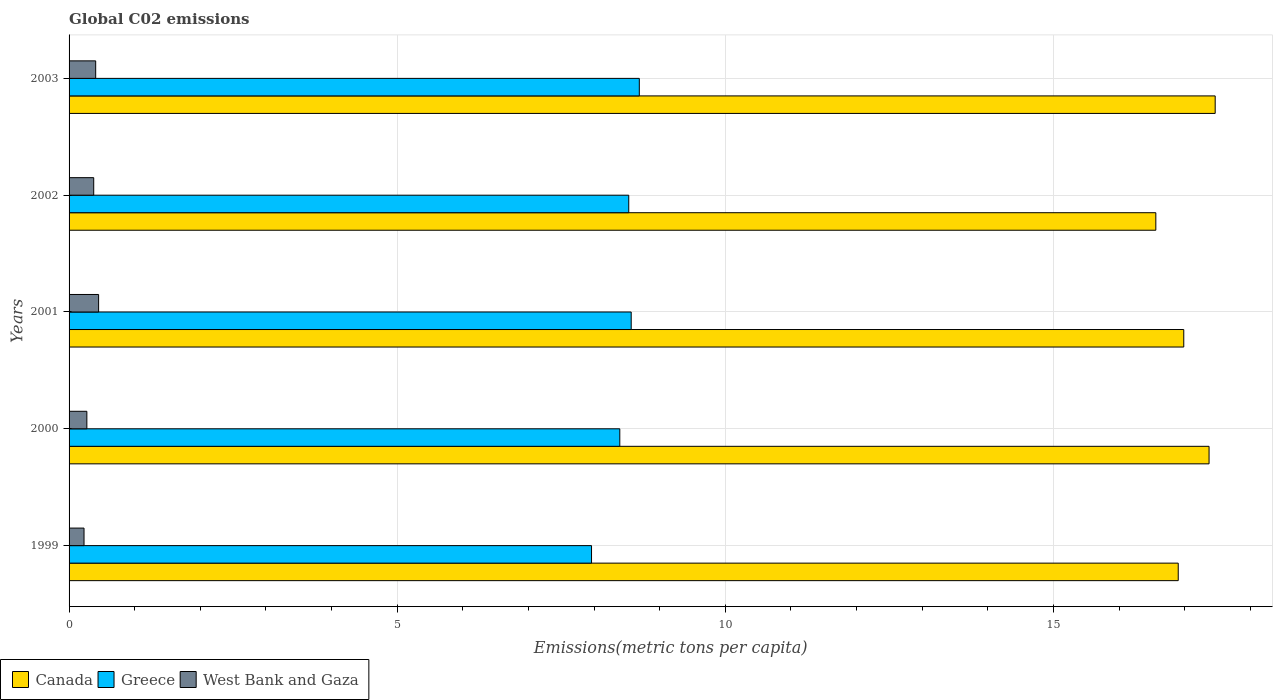How many different coloured bars are there?
Your answer should be compact. 3. How many groups of bars are there?
Provide a succinct answer. 5. Are the number of bars on each tick of the Y-axis equal?
Make the answer very short. Yes. How many bars are there on the 4th tick from the top?
Your answer should be compact. 3. What is the label of the 1st group of bars from the top?
Keep it short and to the point. 2003. In how many cases, is the number of bars for a given year not equal to the number of legend labels?
Your answer should be very brief. 0. What is the amount of CO2 emitted in in Canada in 2000?
Your response must be concise. 17.37. Across all years, what is the maximum amount of CO2 emitted in in West Bank and Gaza?
Keep it short and to the point. 0.45. Across all years, what is the minimum amount of CO2 emitted in in Greece?
Offer a very short reply. 7.96. In which year was the amount of CO2 emitted in in West Bank and Gaza maximum?
Keep it short and to the point. 2001. What is the total amount of CO2 emitted in in Greece in the graph?
Your response must be concise. 42.14. What is the difference between the amount of CO2 emitted in in Canada in 2002 and that in 2003?
Provide a short and direct response. -0.9. What is the difference between the amount of CO2 emitted in in West Bank and Gaza in 2000 and the amount of CO2 emitted in in Canada in 2002?
Offer a terse response. -16.29. What is the average amount of CO2 emitted in in Canada per year?
Your answer should be compact. 17.06. In the year 2002, what is the difference between the amount of CO2 emitted in in West Bank and Gaza and amount of CO2 emitted in in Greece?
Make the answer very short. -8.15. In how many years, is the amount of CO2 emitted in in West Bank and Gaza greater than 8 metric tons per capita?
Offer a very short reply. 0. What is the ratio of the amount of CO2 emitted in in Greece in 1999 to that in 2000?
Give a very brief answer. 0.95. Is the amount of CO2 emitted in in Greece in 1999 less than that in 2000?
Your answer should be compact. Yes. What is the difference between the highest and the second highest amount of CO2 emitted in in Canada?
Your answer should be very brief. 0.09. What is the difference between the highest and the lowest amount of CO2 emitted in in Canada?
Provide a succinct answer. 0.9. Is the sum of the amount of CO2 emitted in in Canada in 2001 and 2002 greater than the maximum amount of CO2 emitted in in West Bank and Gaza across all years?
Keep it short and to the point. Yes. What does the 3rd bar from the bottom in 2002 represents?
Your answer should be very brief. West Bank and Gaza. Is it the case that in every year, the sum of the amount of CO2 emitted in in West Bank and Gaza and amount of CO2 emitted in in Greece is greater than the amount of CO2 emitted in in Canada?
Provide a succinct answer. No. How many bars are there?
Your answer should be compact. 15. Are all the bars in the graph horizontal?
Provide a succinct answer. Yes. What is the difference between two consecutive major ticks on the X-axis?
Your answer should be very brief. 5. How are the legend labels stacked?
Ensure brevity in your answer.  Horizontal. What is the title of the graph?
Provide a short and direct response. Global C02 emissions. Does "Syrian Arab Republic" appear as one of the legend labels in the graph?
Keep it short and to the point. No. What is the label or title of the X-axis?
Offer a very short reply. Emissions(metric tons per capita). What is the label or title of the Y-axis?
Keep it short and to the point. Years. What is the Emissions(metric tons per capita) of Canada in 1999?
Offer a terse response. 16.9. What is the Emissions(metric tons per capita) of Greece in 1999?
Make the answer very short. 7.96. What is the Emissions(metric tons per capita) of West Bank and Gaza in 1999?
Offer a very short reply. 0.23. What is the Emissions(metric tons per capita) of Canada in 2000?
Give a very brief answer. 17.37. What is the Emissions(metric tons per capita) of Greece in 2000?
Ensure brevity in your answer.  8.39. What is the Emissions(metric tons per capita) in West Bank and Gaza in 2000?
Offer a terse response. 0.27. What is the Emissions(metric tons per capita) in Canada in 2001?
Your answer should be very brief. 16.99. What is the Emissions(metric tons per capita) in Greece in 2001?
Offer a terse response. 8.57. What is the Emissions(metric tons per capita) in West Bank and Gaza in 2001?
Your answer should be compact. 0.45. What is the Emissions(metric tons per capita) in Canada in 2002?
Provide a succinct answer. 16.56. What is the Emissions(metric tons per capita) of Greece in 2002?
Keep it short and to the point. 8.53. What is the Emissions(metric tons per capita) in West Bank and Gaza in 2002?
Make the answer very short. 0.38. What is the Emissions(metric tons per capita) of Canada in 2003?
Provide a short and direct response. 17.46. What is the Emissions(metric tons per capita) of Greece in 2003?
Your answer should be compact. 8.69. What is the Emissions(metric tons per capita) of West Bank and Gaza in 2003?
Your answer should be very brief. 0.41. Across all years, what is the maximum Emissions(metric tons per capita) in Canada?
Your answer should be very brief. 17.46. Across all years, what is the maximum Emissions(metric tons per capita) in Greece?
Provide a succinct answer. 8.69. Across all years, what is the maximum Emissions(metric tons per capita) of West Bank and Gaza?
Give a very brief answer. 0.45. Across all years, what is the minimum Emissions(metric tons per capita) in Canada?
Your response must be concise. 16.56. Across all years, what is the minimum Emissions(metric tons per capita) in Greece?
Provide a short and direct response. 7.96. Across all years, what is the minimum Emissions(metric tons per capita) of West Bank and Gaza?
Give a very brief answer. 0.23. What is the total Emissions(metric tons per capita) in Canada in the graph?
Your response must be concise. 85.28. What is the total Emissions(metric tons per capita) of Greece in the graph?
Your answer should be very brief. 42.14. What is the total Emissions(metric tons per capita) in West Bank and Gaza in the graph?
Your answer should be compact. 1.73. What is the difference between the Emissions(metric tons per capita) of Canada in 1999 and that in 2000?
Provide a succinct answer. -0.47. What is the difference between the Emissions(metric tons per capita) of Greece in 1999 and that in 2000?
Give a very brief answer. -0.43. What is the difference between the Emissions(metric tons per capita) in West Bank and Gaza in 1999 and that in 2000?
Your answer should be compact. -0.04. What is the difference between the Emissions(metric tons per capita) in Canada in 1999 and that in 2001?
Provide a succinct answer. -0.08. What is the difference between the Emissions(metric tons per capita) of Greece in 1999 and that in 2001?
Offer a terse response. -0.6. What is the difference between the Emissions(metric tons per capita) of West Bank and Gaza in 1999 and that in 2001?
Provide a short and direct response. -0.22. What is the difference between the Emissions(metric tons per capita) of Canada in 1999 and that in 2002?
Your answer should be very brief. 0.34. What is the difference between the Emissions(metric tons per capita) of Greece in 1999 and that in 2002?
Make the answer very short. -0.57. What is the difference between the Emissions(metric tons per capita) of West Bank and Gaza in 1999 and that in 2002?
Provide a succinct answer. -0.15. What is the difference between the Emissions(metric tons per capita) of Canada in 1999 and that in 2003?
Your answer should be compact. -0.56. What is the difference between the Emissions(metric tons per capita) in Greece in 1999 and that in 2003?
Ensure brevity in your answer.  -0.73. What is the difference between the Emissions(metric tons per capita) in West Bank and Gaza in 1999 and that in 2003?
Your response must be concise. -0.18. What is the difference between the Emissions(metric tons per capita) in Canada in 2000 and that in 2001?
Your answer should be very brief. 0.39. What is the difference between the Emissions(metric tons per capita) of Greece in 2000 and that in 2001?
Make the answer very short. -0.17. What is the difference between the Emissions(metric tons per capita) in West Bank and Gaza in 2000 and that in 2001?
Offer a very short reply. -0.18. What is the difference between the Emissions(metric tons per capita) in Canada in 2000 and that in 2002?
Your answer should be compact. 0.81. What is the difference between the Emissions(metric tons per capita) of Greece in 2000 and that in 2002?
Your answer should be very brief. -0.14. What is the difference between the Emissions(metric tons per capita) of West Bank and Gaza in 2000 and that in 2002?
Give a very brief answer. -0.1. What is the difference between the Emissions(metric tons per capita) of Canada in 2000 and that in 2003?
Keep it short and to the point. -0.09. What is the difference between the Emissions(metric tons per capita) of Greece in 2000 and that in 2003?
Offer a terse response. -0.3. What is the difference between the Emissions(metric tons per capita) of West Bank and Gaza in 2000 and that in 2003?
Keep it short and to the point. -0.13. What is the difference between the Emissions(metric tons per capita) of Canada in 2001 and that in 2002?
Ensure brevity in your answer.  0.43. What is the difference between the Emissions(metric tons per capita) in Greece in 2001 and that in 2002?
Give a very brief answer. 0.04. What is the difference between the Emissions(metric tons per capita) of West Bank and Gaza in 2001 and that in 2002?
Your response must be concise. 0.07. What is the difference between the Emissions(metric tons per capita) in Canada in 2001 and that in 2003?
Offer a terse response. -0.48. What is the difference between the Emissions(metric tons per capita) of Greece in 2001 and that in 2003?
Give a very brief answer. -0.12. What is the difference between the Emissions(metric tons per capita) of West Bank and Gaza in 2001 and that in 2003?
Your response must be concise. 0.04. What is the difference between the Emissions(metric tons per capita) of Canada in 2002 and that in 2003?
Your answer should be compact. -0.9. What is the difference between the Emissions(metric tons per capita) in Greece in 2002 and that in 2003?
Offer a very short reply. -0.16. What is the difference between the Emissions(metric tons per capita) in West Bank and Gaza in 2002 and that in 2003?
Your answer should be very brief. -0.03. What is the difference between the Emissions(metric tons per capita) of Canada in 1999 and the Emissions(metric tons per capita) of Greece in 2000?
Offer a terse response. 8.51. What is the difference between the Emissions(metric tons per capita) in Canada in 1999 and the Emissions(metric tons per capita) in West Bank and Gaza in 2000?
Make the answer very short. 16.63. What is the difference between the Emissions(metric tons per capita) in Greece in 1999 and the Emissions(metric tons per capita) in West Bank and Gaza in 2000?
Provide a short and direct response. 7.69. What is the difference between the Emissions(metric tons per capita) in Canada in 1999 and the Emissions(metric tons per capita) in Greece in 2001?
Your answer should be compact. 8.34. What is the difference between the Emissions(metric tons per capita) of Canada in 1999 and the Emissions(metric tons per capita) of West Bank and Gaza in 2001?
Offer a terse response. 16.45. What is the difference between the Emissions(metric tons per capita) of Greece in 1999 and the Emissions(metric tons per capita) of West Bank and Gaza in 2001?
Provide a short and direct response. 7.51. What is the difference between the Emissions(metric tons per capita) of Canada in 1999 and the Emissions(metric tons per capita) of Greece in 2002?
Provide a succinct answer. 8.37. What is the difference between the Emissions(metric tons per capita) of Canada in 1999 and the Emissions(metric tons per capita) of West Bank and Gaza in 2002?
Ensure brevity in your answer.  16.53. What is the difference between the Emissions(metric tons per capita) in Greece in 1999 and the Emissions(metric tons per capita) in West Bank and Gaza in 2002?
Keep it short and to the point. 7.59. What is the difference between the Emissions(metric tons per capita) in Canada in 1999 and the Emissions(metric tons per capita) in Greece in 2003?
Offer a terse response. 8.21. What is the difference between the Emissions(metric tons per capita) of Canada in 1999 and the Emissions(metric tons per capita) of West Bank and Gaza in 2003?
Make the answer very short. 16.5. What is the difference between the Emissions(metric tons per capita) of Greece in 1999 and the Emissions(metric tons per capita) of West Bank and Gaza in 2003?
Give a very brief answer. 7.56. What is the difference between the Emissions(metric tons per capita) of Canada in 2000 and the Emissions(metric tons per capita) of Greece in 2001?
Your answer should be compact. 8.81. What is the difference between the Emissions(metric tons per capita) of Canada in 2000 and the Emissions(metric tons per capita) of West Bank and Gaza in 2001?
Your answer should be very brief. 16.92. What is the difference between the Emissions(metric tons per capita) of Greece in 2000 and the Emissions(metric tons per capita) of West Bank and Gaza in 2001?
Provide a short and direct response. 7.94. What is the difference between the Emissions(metric tons per capita) of Canada in 2000 and the Emissions(metric tons per capita) of Greece in 2002?
Provide a succinct answer. 8.84. What is the difference between the Emissions(metric tons per capita) of Canada in 2000 and the Emissions(metric tons per capita) of West Bank and Gaza in 2002?
Your answer should be compact. 16.99. What is the difference between the Emissions(metric tons per capita) of Greece in 2000 and the Emissions(metric tons per capita) of West Bank and Gaza in 2002?
Keep it short and to the point. 8.02. What is the difference between the Emissions(metric tons per capita) in Canada in 2000 and the Emissions(metric tons per capita) in Greece in 2003?
Your response must be concise. 8.68. What is the difference between the Emissions(metric tons per capita) in Canada in 2000 and the Emissions(metric tons per capita) in West Bank and Gaza in 2003?
Provide a succinct answer. 16.96. What is the difference between the Emissions(metric tons per capita) of Greece in 2000 and the Emissions(metric tons per capita) of West Bank and Gaza in 2003?
Keep it short and to the point. 7.99. What is the difference between the Emissions(metric tons per capita) in Canada in 2001 and the Emissions(metric tons per capita) in Greece in 2002?
Give a very brief answer. 8.46. What is the difference between the Emissions(metric tons per capita) of Canada in 2001 and the Emissions(metric tons per capita) of West Bank and Gaza in 2002?
Your answer should be very brief. 16.61. What is the difference between the Emissions(metric tons per capita) of Greece in 2001 and the Emissions(metric tons per capita) of West Bank and Gaza in 2002?
Offer a very short reply. 8.19. What is the difference between the Emissions(metric tons per capita) of Canada in 2001 and the Emissions(metric tons per capita) of Greece in 2003?
Keep it short and to the point. 8.3. What is the difference between the Emissions(metric tons per capita) of Canada in 2001 and the Emissions(metric tons per capita) of West Bank and Gaza in 2003?
Make the answer very short. 16.58. What is the difference between the Emissions(metric tons per capita) of Greece in 2001 and the Emissions(metric tons per capita) of West Bank and Gaza in 2003?
Make the answer very short. 8.16. What is the difference between the Emissions(metric tons per capita) in Canada in 2002 and the Emissions(metric tons per capita) in Greece in 2003?
Your answer should be very brief. 7.87. What is the difference between the Emissions(metric tons per capita) of Canada in 2002 and the Emissions(metric tons per capita) of West Bank and Gaza in 2003?
Make the answer very short. 16.15. What is the difference between the Emissions(metric tons per capita) of Greece in 2002 and the Emissions(metric tons per capita) of West Bank and Gaza in 2003?
Provide a succinct answer. 8.12. What is the average Emissions(metric tons per capita) of Canada per year?
Your answer should be very brief. 17.06. What is the average Emissions(metric tons per capita) of Greece per year?
Give a very brief answer. 8.43. What is the average Emissions(metric tons per capita) of West Bank and Gaza per year?
Offer a terse response. 0.35. In the year 1999, what is the difference between the Emissions(metric tons per capita) in Canada and Emissions(metric tons per capita) in Greece?
Make the answer very short. 8.94. In the year 1999, what is the difference between the Emissions(metric tons per capita) of Canada and Emissions(metric tons per capita) of West Bank and Gaza?
Your answer should be compact. 16.67. In the year 1999, what is the difference between the Emissions(metric tons per capita) of Greece and Emissions(metric tons per capita) of West Bank and Gaza?
Your answer should be compact. 7.73. In the year 2000, what is the difference between the Emissions(metric tons per capita) of Canada and Emissions(metric tons per capita) of Greece?
Provide a short and direct response. 8.98. In the year 2000, what is the difference between the Emissions(metric tons per capita) in Canada and Emissions(metric tons per capita) in West Bank and Gaza?
Keep it short and to the point. 17.1. In the year 2000, what is the difference between the Emissions(metric tons per capita) in Greece and Emissions(metric tons per capita) in West Bank and Gaza?
Keep it short and to the point. 8.12. In the year 2001, what is the difference between the Emissions(metric tons per capita) of Canada and Emissions(metric tons per capita) of Greece?
Your response must be concise. 8.42. In the year 2001, what is the difference between the Emissions(metric tons per capita) of Canada and Emissions(metric tons per capita) of West Bank and Gaza?
Make the answer very short. 16.53. In the year 2001, what is the difference between the Emissions(metric tons per capita) in Greece and Emissions(metric tons per capita) in West Bank and Gaza?
Ensure brevity in your answer.  8.12. In the year 2002, what is the difference between the Emissions(metric tons per capita) of Canada and Emissions(metric tons per capita) of Greece?
Offer a very short reply. 8.03. In the year 2002, what is the difference between the Emissions(metric tons per capita) of Canada and Emissions(metric tons per capita) of West Bank and Gaza?
Keep it short and to the point. 16.18. In the year 2002, what is the difference between the Emissions(metric tons per capita) of Greece and Emissions(metric tons per capita) of West Bank and Gaza?
Provide a succinct answer. 8.15. In the year 2003, what is the difference between the Emissions(metric tons per capita) in Canada and Emissions(metric tons per capita) in Greece?
Your answer should be very brief. 8.77. In the year 2003, what is the difference between the Emissions(metric tons per capita) in Canada and Emissions(metric tons per capita) in West Bank and Gaza?
Give a very brief answer. 17.06. In the year 2003, what is the difference between the Emissions(metric tons per capita) of Greece and Emissions(metric tons per capita) of West Bank and Gaza?
Provide a short and direct response. 8.28. What is the ratio of the Emissions(metric tons per capita) of Greece in 1999 to that in 2000?
Keep it short and to the point. 0.95. What is the ratio of the Emissions(metric tons per capita) in West Bank and Gaza in 1999 to that in 2000?
Your answer should be very brief. 0.84. What is the ratio of the Emissions(metric tons per capita) in Canada in 1999 to that in 2001?
Offer a terse response. 0.99. What is the ratio of the Emissions(metric tons per capita) of Greece in 1999 to that in 2001?
Offer a terse response. 0.93. What is the ratio of the Emissions(metric tons per capita) of West Bank and Gaza in 1999 to that in 2001?
Your answer should be compact. 0.51. What is the ratio of the Emissions(metric tons per capita) of Canada in 1999 to that in 2002?
Your answer should be very brief. 1.02. What is the ratio of the Emissions(metric tons per capita) in Greece in 1999 to that in 2002?
Offer a terse response. 0.93. What is the ratio of the Emissions(metric tons per capita) of West Bank and Gaza in 1999 to that in 2002?
Provide a short and direct response. 0.61. What is the ratio of the Emissions(metric tons per capita) in Canada in 1999 to that in 2003?
Make the answer very short. 0.97. What is the ratio of the Emissions(metric tons per capita) of Greece in 1999 to that in 2003?
Provide a short and direct response. 0.92. What is the ratio of the Emissions(metric tons per capita) of West Bank and Gaza in 1999 to that in 2003?
Provide a short and direct response. 0.56. What is the ratio of the Emissions(metric tons per capita) in Canada in 2000 to that in 2001?
Ensure brevity in your answer.  1.02. What is the ratio of the Emissions(metric tons per capita) of Greece in 2000 to that in 2001?
Keep it short and to the point. 0.98. What is the ratio of the Emissions(metric tons per capita) in West Bank and Gaza in 2000 to that in 2001?
Your response must be concise. 0.6. What is the ratio of the Emissions(metric tons per capita) of Canada in 2000 to that in 2002?
Your answer should be compact. 1.05. What is the ratio of the Emissions(metric tons per capita) of Greece in 2000 to that in 2002?
Ensure brevity in your answer.  0.98. What is the ratio of the Emissions(metric tons per capita) of West Bank and Gaza in 2000 to that in 2002?
Keep it short and to the point. 0.72. What is the ratio of the Emissions(metric tons per capita) of Greece in 2000 to that in 2003?
Provide a short and direct response. 0.97. What is the ratio of the Emissions(metric tons per capita) in West Bank and Gaza in 2000 to that in 2003?
Ensure brevity in your answer.  0.67. What is the ratio of the Emissions(metric tons per capita) of Canada in 2001 to that in 2002?
Your answer should be compact. 1.03. What is the ratio of the Emissions(metric tons per capita) of West Bank and Gaza in 2001 to that in 2002?
Keep it short and to the point. 1.2. What is the ratio of the Emissions(metric tons per capita) in Canada in 2001 to that in 2003?
Offer a terse response. 0.97. What is the ratio of the Emissions(metric tons per capita) in Greece in 2001 to that in 2003?
Your answer should be compact. 0.99. What is the ratio of the Emissions(metric tons per capita) of West Bank and Gaza in 2001 to that in 2003?
Offer a terse response. 1.11. What is the ratio of the Emissions(metric tons per capita) of Canada in 2002 to that in 2003?
Make the answer very short. 0.95. What is the ratio of the Emissions(metric tons per capita) of Greece in 2002 to that in 2003?
Your answer should be very brief. 0.98. What is the ratio of the Emissions(metric tons per capita) of West Bank and Gaza in 2002 to that in 2003?
Your response must be concise. 0.93. What is the difference between the highest and the second highest Emissions(metric tons per capita) in Canada?
Provide a short and direct response. 0.09. What is the difference between the highest and the second highest Emissions(metric tons per capita) in Greece?
Make the answer very short. 0.12. What is the difference between the highest and the second highest Emissions(metric tons per capita) in West Bank and Gaza?
Give a very brief answer. 0.04. What is the difference between the highest and the lowest Emissions(metric tons per capita) of Canada?
Make the answer very short. 0.9. What is the difference between the highest and the lowest Emissions(metric tons per capita) of Greece?
Offer a very short reply. 0.73. What is the difference between the highest and the lowest Emissions(metric tons per capita) in West Bank and Gaza?
Make the answer very short. 0.22. 